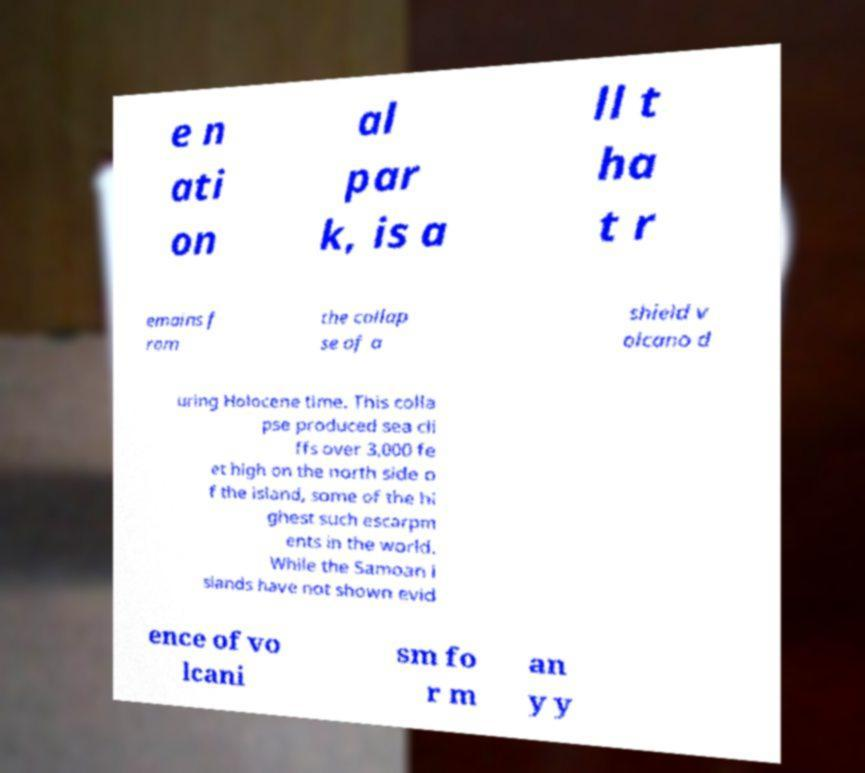What messages or text are displayed in this image? I need them in a readable, typed format. e n ati on al par k, is a ll t ha t r emains f rom the collap se of a shield v olcano d uring Holocene time. This colla pse produced sea cli ffs over 3,000 fe et high on the north side o f the island, some of the hi ghest such escarpm ents in the world. While the Samoan i slands have not shown evid ence of vo lcani sm fo r m an y y 